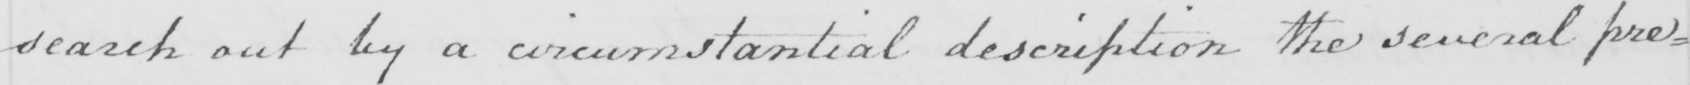Can you read and transcribe this handwriting? search out by a circumstantial description the several pre= 